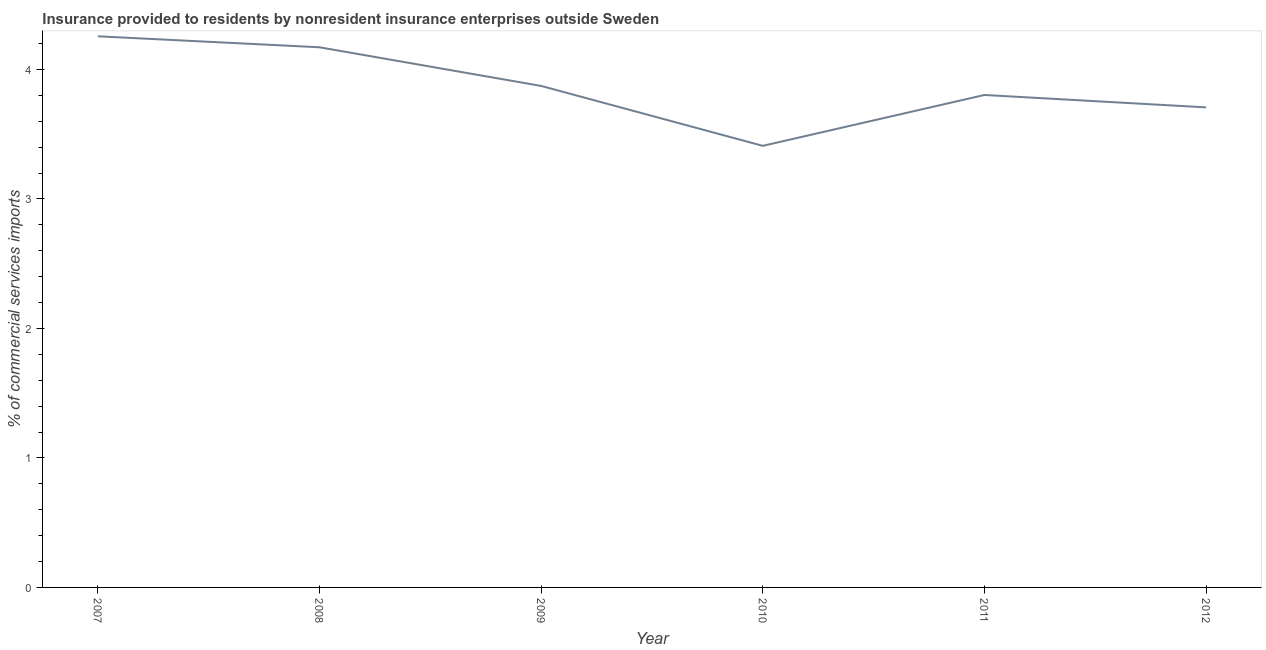What is the insurance provided by non-residents in 2008?
Keep it short and to the point. 4.17. Across all years, what is the maximum insurance provided by non-residents?
Your response must be concise. 4.26. Across all years, what is the minimum insurance provided by non-residents?
Make the answer very short. 3.41. In which year was the insurance provided by non-residents maximum?
Provide a short and direct response. 2007. What is the sum of the insurance provided by non-residents?
Offer a very short reply. 23.22. What is the difference between the insurance provided by non-residents in 2007 and 2008?
Provide a short and direct response. 0.08. What is the average insurance provided by non-residents per year?
Make the answer very short. 3.87. What is the median insurance provided by non-residents?
Offer a very short reply. 3.84. In how many years, is the insurance provided by non-residents greater than 2.6 %?
Ensure brevity in your answer.  6. What is the ratio of the insurance provided by non-residents in 2010 to that in 2011?
Ensure brevity in your answer.  0.9. Is the difference between the insurance provided by non-residents in 2007 and 2010 greater than the difference between any two years?
Offer a terse response. Yes. What is the difference between the highest and the second highest insurance provided by non-residents?
Provide a short and direct response. 0.08. What is the difference between the highest and the lowest insurance provided by non-residents?
Provide a short and direct response. 0.85. In how many years, is the insurance provided by non-residents greater than the average insurance provided by non-residents taken over all years?
Your answer should be compact. 3. How many lines are there?
Your response must be concise. 1. What is the title of the graph?
Offer a terse response. Insurance provided to residents by nonresident insurance enterprises outside Sweden. What is the label or title of the X-axis?
Offer a very short reply. Year. What is the label or title of the Y-axis?
Give a very brief answer. % of commercial services imports. What is the % of commercial services imports of 2007?
Your answer should be compact. 4.26. What is the % of commercial services imports of 2008?
Your answer should be very brief. 4.17. What is the % of commercial services imports in 2009?
Provide a succinct answer. 3.87. What is the % of commercial services imports in 2010?
Keep it short and to the point. 3.41. What is the % of commercial services imports of 2011?
Provide a succinct answer. 3.8. What is the % of commercial services imports of 2012?
Offer a very short reply. 3.71. What is the difference between the % of commercial services imports in 2007 and 2008?
Make the answer very short. 0.08. What is the difference between the % of commercial services imports in 2007 and 2009?
Offer a very short reply. 0.38. What is the difference between the % of commercial services imports in 2007 and 2010?
Your answer should be compact. 0.85. What is the difference between the % of commercial services imports in 2007 and 2011?
Provide a short and direct response. 0.45. What is the difference between the % of commercial services imports in 2007 and 2012?
Provide a succinct answer. 0.55. What is the difference between the % of commercial services imports in 2008 and 2009?
Give a very brief answer. 0.3. What is the difference between the % of commercial services imports in 2008 and 2010?
Your answer should be very brief. 0.76. What is the difference between the % of commercial services imports in 2008 and 2011?
Provide a short and direct response. 0.37. What is the difference between the % of commercial services imports in 2008 and 2012?
Your response must be concise. 0.46. What is the difference between the % of commercial services imports in 2009 and 2010?
Make the answer very short. 0.46. What is the difference between the % of commercial services imports in 2009 and 2011?
Offer a terse response. 0.07. What is the difference between the % of commercial services imports in 2009 and 2012?
Your answer should be compact. 0.17. What is the difference between the % of commercial services imports in 2010 and 2011?
Provide a succinct answer. -0.39. What is the difference between the % of commercial services imports in 2010 and 2012?
Provide a short and direct response. -0.3. What is the difference between the % of commercial services imports in 2011 and 2012?
Provide a succinct answer. 0.1. What is the ratio of the % of commercial services imports in 2007 to that in 2008?
Your answer should be very brief. 1.02. What is the ratio of the % of commercial services imports in 2007 to that in 2009?
Make the answer very short. 1.1. What is the ratio of the % of commercial services imports in 2007 to that in 2010?
Provide a succinct answer. 1.25. What is the ratio of the % of commercial services imports in 2007 to that in 2011?
Keep it short and to the point. 1.12. What is the ratio of the % of commercial services imports in 2007 to that in 2012?
Your response must be concise. 1.15. What is the ratio of the % of commercial services imports in 2008 to that in 2009?
Your answer should be compact. 1.08. What is the ratio of the % of commercial services imports in 2008 to that in 2010?
Offer a very short reply. 1.22. What is the ratio of the % of commercial services imports in 2008 to that in 2011?
Give a very brief answer. 1.1. What is the ratio of the % of commercial services imports in 2009 to that in 2010?
Give a very brief answer. 1.14. What is the ratio of the % of commercial services imports in 2009 to that in 2011?
Provide a short and direct response. 1.02. What is the ratio of the % of commercial services imports in 2009 to that in 2012?
Provide a short and direct response. 1.04. What is the ratio of the % of commercial services imports in 2010 to that in 2011?
Your answer should be very brief. 0.9. What is the ratio of the % of commercial services imports in 2010 to that in 2012?
Provide a succinct answer. 0.92. What is the ratio of the % of commercial services imports in 2011 to that in 2012?
Your answer should be compact. 1.03. 